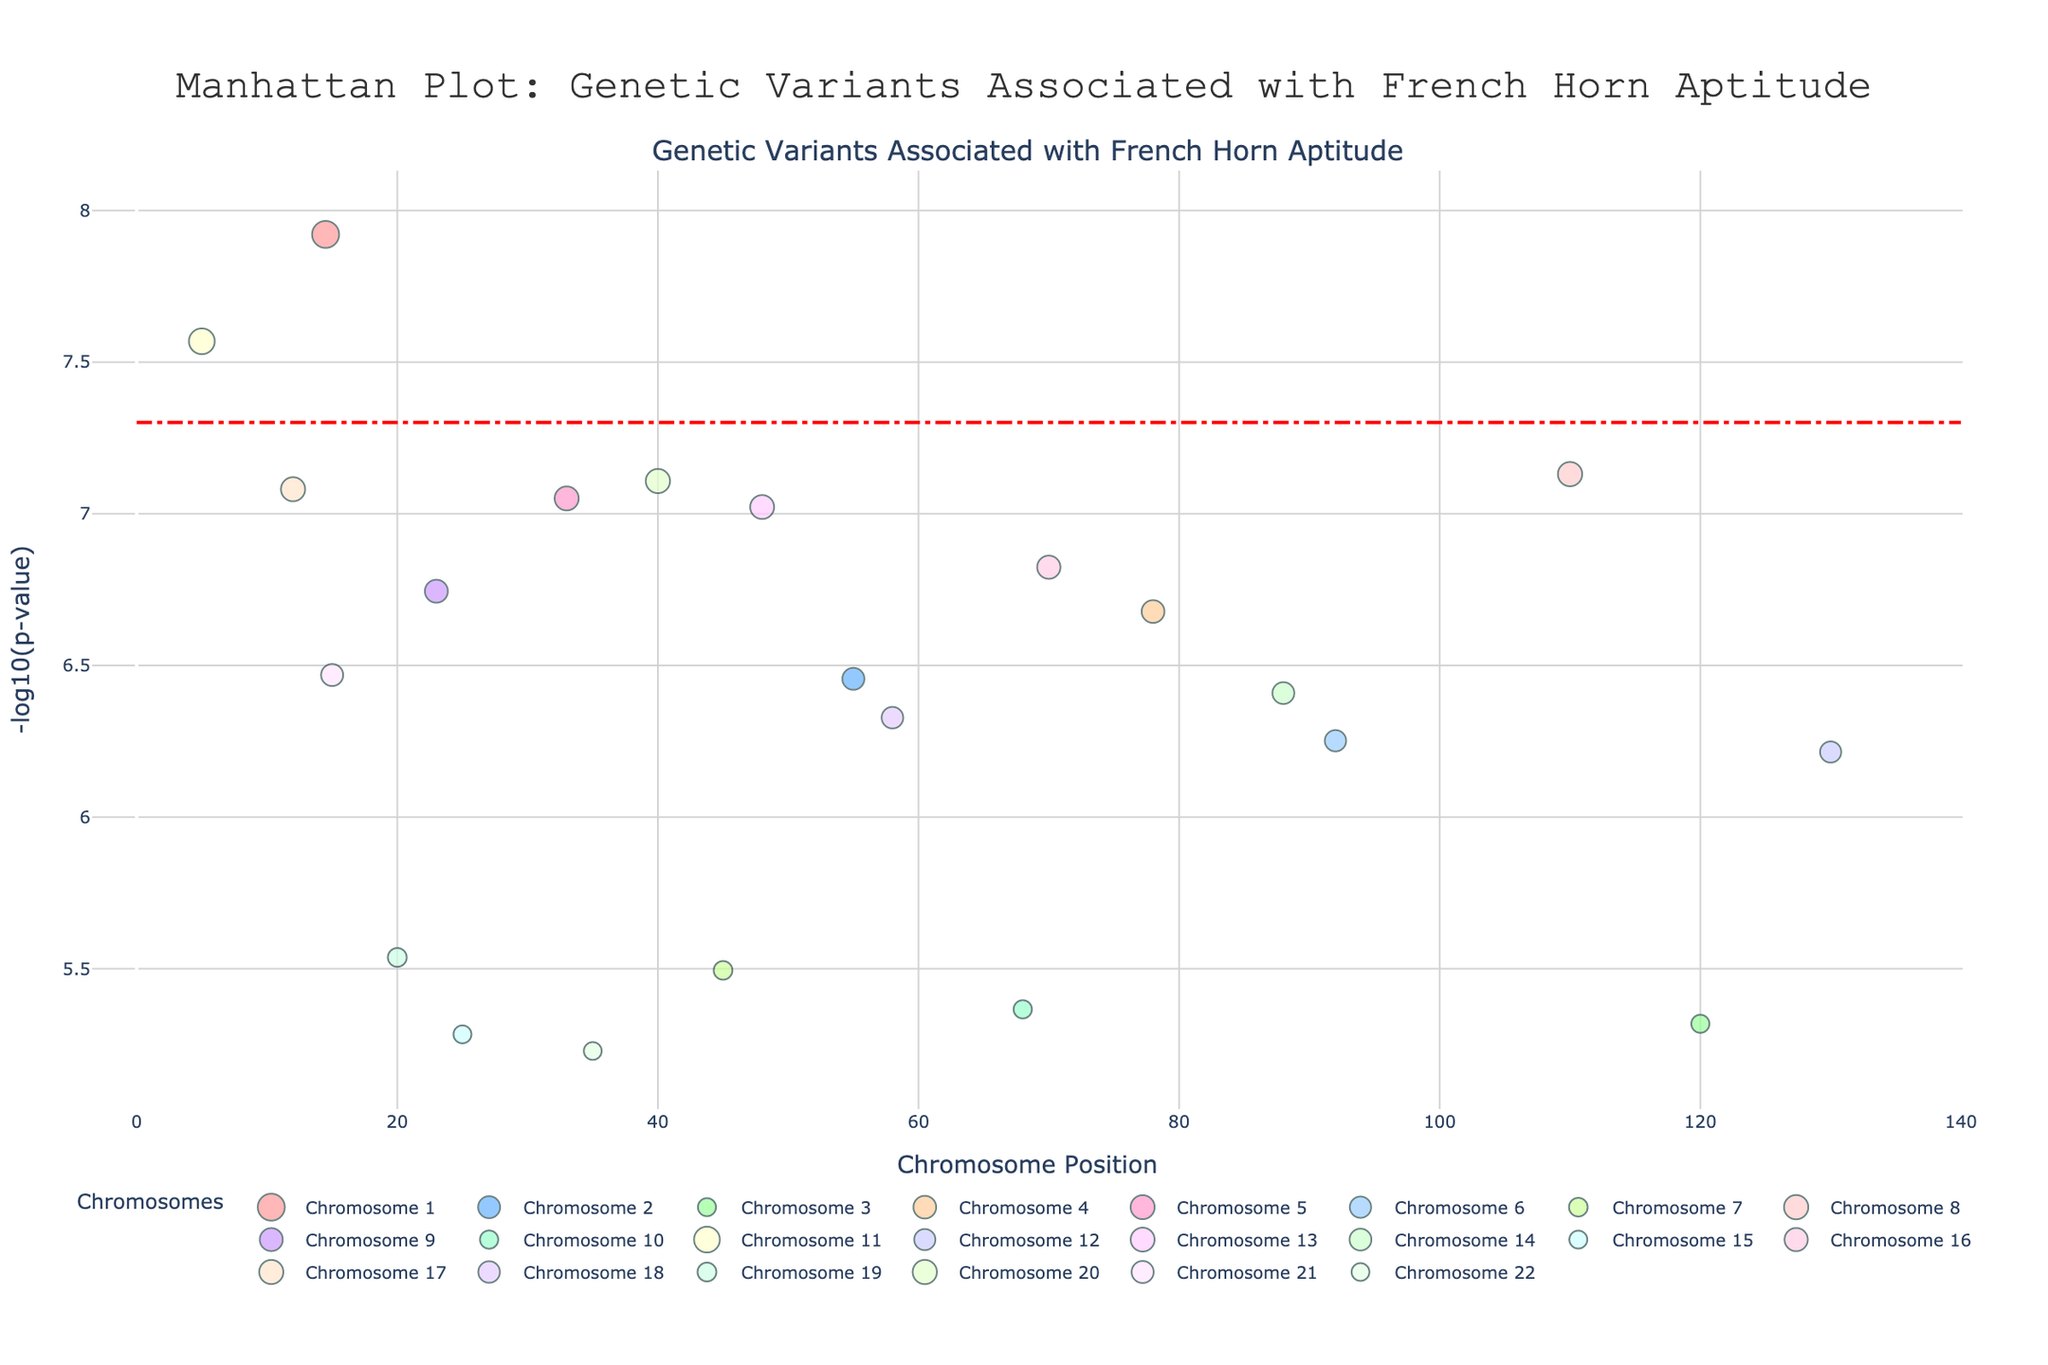what is the title of the figure? The title of the figure is located at the top and center of the plot. By looking there, we can read the title directly.
Answer: Manhattan Plot: Genetic Variants Associated with French Horn Aptitude Which chromosome has the genetic variant with the smallest p-value? The -log10(p-value) is highest for the genetic variant on chromosome 1 since it has the largest marker size and the highest position on the y-axis. This corresponds to the smallest p-value.
Answer: Chromosome 1 How many chromosomes are represented in the plot? Each unique chromosome is displayed with a different color in the legend. By counting the number of chromosome labels in the legend, we can determine the total number of chromosomes.
Answer: 22 What is the trait associated with the most significant p-value on chromosome 5? By locating chromosome 5's color and high -log10(p-value) values in the plot, we can look at the hover information to find the associated trait with the most significant p-value.
Answer: Endurance Which trait is located at the highest position (the most significant) in the plot? The highest position in the plot (on the y-axis) corresponds to the trait with the smallest p-value. By checking the hover text at that highest point, we can identify the trait.
Answer: Embouchure control How many traits are associated with genetic variants on chromosome 7? By identifying the color corresponding to chromosome 7 and counting the number of markers (data points), we can see how many traits are associated with this chromosome.
Answer: 1 What is the p-value threshold indicated by the horizontal dashed red line? The horizontal dashed red line represents a significance threshold. By checking the y-axis value where this line is drawn, we can determine the p-value threshold shown as -log10(p-value). The threshold corresponding to the red dashed line is about 5e-8, which translates to a y-axis value of -log10(5e-8).
Answer: 5e-8 What is the second most significant trait on chromosome 11? By locating chromosome 11's color on the plot and finding the second highest -log10(p-value) marker, we can identify the trait associated with it by the hover text.
Answer: Circular breathing aptitude 